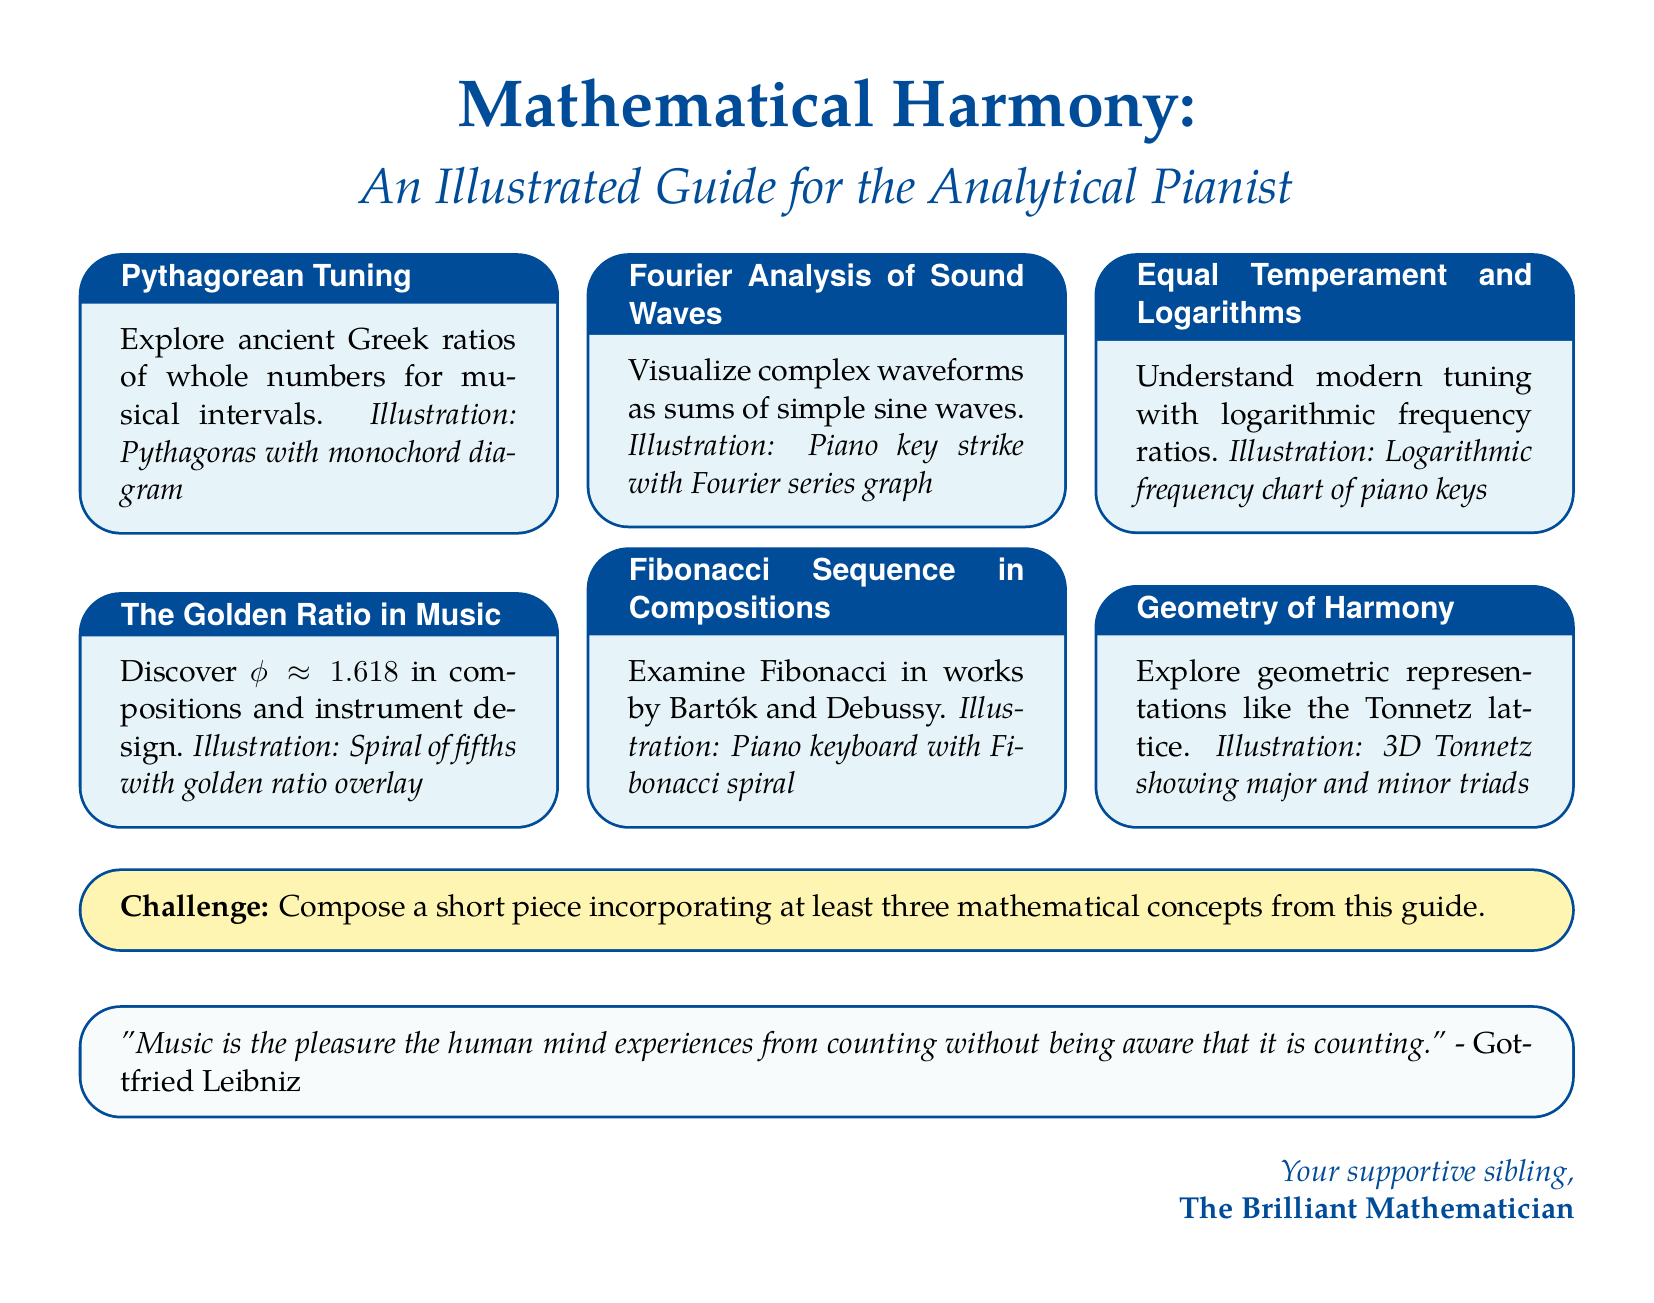What is the title of the guide? The title is prominently displayed at the beginning of the document, which outlines its content focus.
Answer: Mathematical Harmony How many sections are in the document? The document lists six distinct sections that describe various mathematical principles related to music.
Answer: Six What mathematical concept is associated with ratios of whole numbers? This concept is explored in the first section, focusing on ancient musical intervals derived from whole number ratios.
Answer: Pythagorean Tuning Which famous sequence is mentioned in relation to composers Bartók and Debussy? The document discusses a specific mathematical sequence that appears in compositions by these composers.
Answer: Fibonacci Sequence What is the approximate value of the golden ratio mentioned in the guide? This specific value is provided to illustrate its significance in compositions and design within music.
Answer: 1.618 What type of illustration is included for the Fourier Analysis section? The document refers to an illustration that visually depicts the mathematical concept associated with sound waves.
Answer: Piano key strike with Fourier series graph What challenge is presented to the reader at the end of the document? The document concludes with a request for readers to engage creatively using mathematical principles discussed throughout.
Answer: Compose a short piece incorporating at least three mathematical concepts Which mathematician's quote appears in the document? The closing section of the document features an insightful quote highlighting the relationship between music and mathematics.
Answer: Gottfried Leibniz 